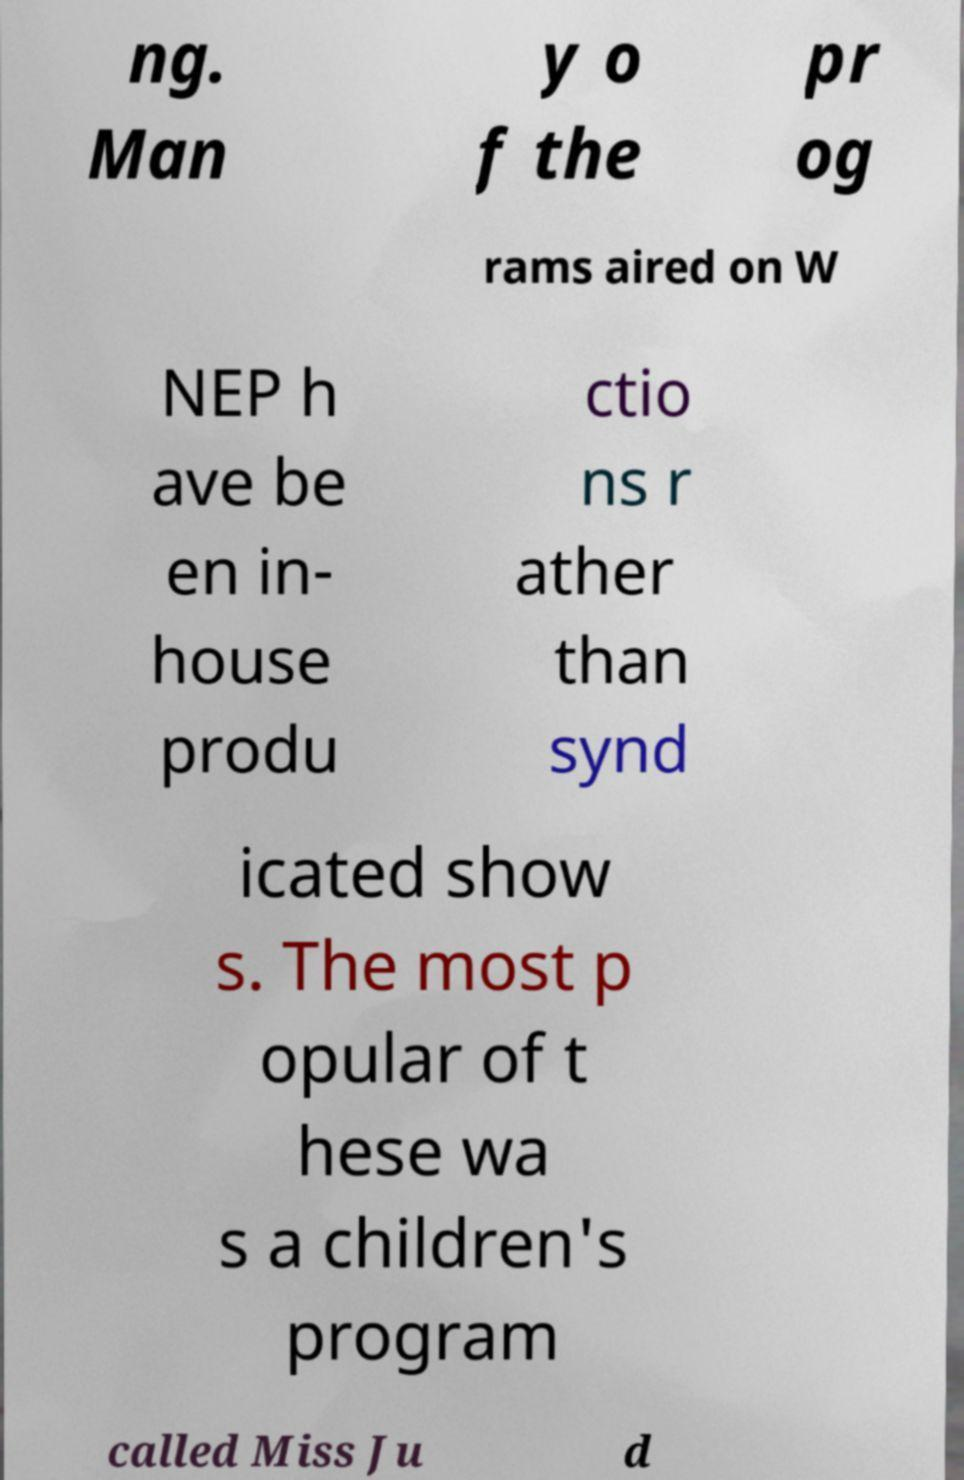Please identify and transcribe the text found in this image. ng. Man y o f the pr og rams aired on W NEP h ave be en in- house produ ctio ns r ather than synd icated show s. The most p opular of t hese wa s a children's program called Miss Ju d 